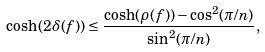Convert formula to latex. <formula><loc_0><loc_0><loc_500><loc_500>\cosh ( 2 \delta ( f ) ) \leq \frac { \cosh ( \rho ( f ) ) - \cos ^ { 2 } ( \pi / n ) } { \sin ^ { 2 } ( \pi / n ) } ,</formula> 